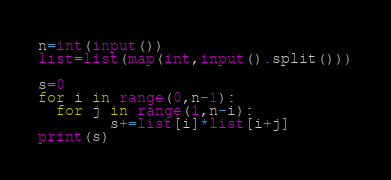Convert code to text. <code><loc_0><loc_0><loc_500><loc_500><_Python_>n=int(input())
list=list(map(int,input().split()))

s=0
for i in range(0,n-1):
  for j in range(1,n-i):
        s+=list[i]*list[i+j]
print(s)</code> 